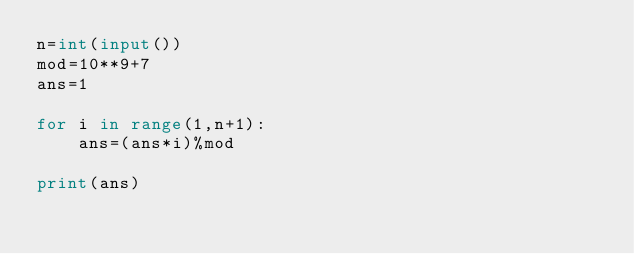<code> <loc_0><loc_0><loc_500><loc_500><_Python_>n=int(input())
mod=10**9+7
ans=1

for i in range(1,n+1):
    ans=(ans*i)%mod

print(ans)</code> 